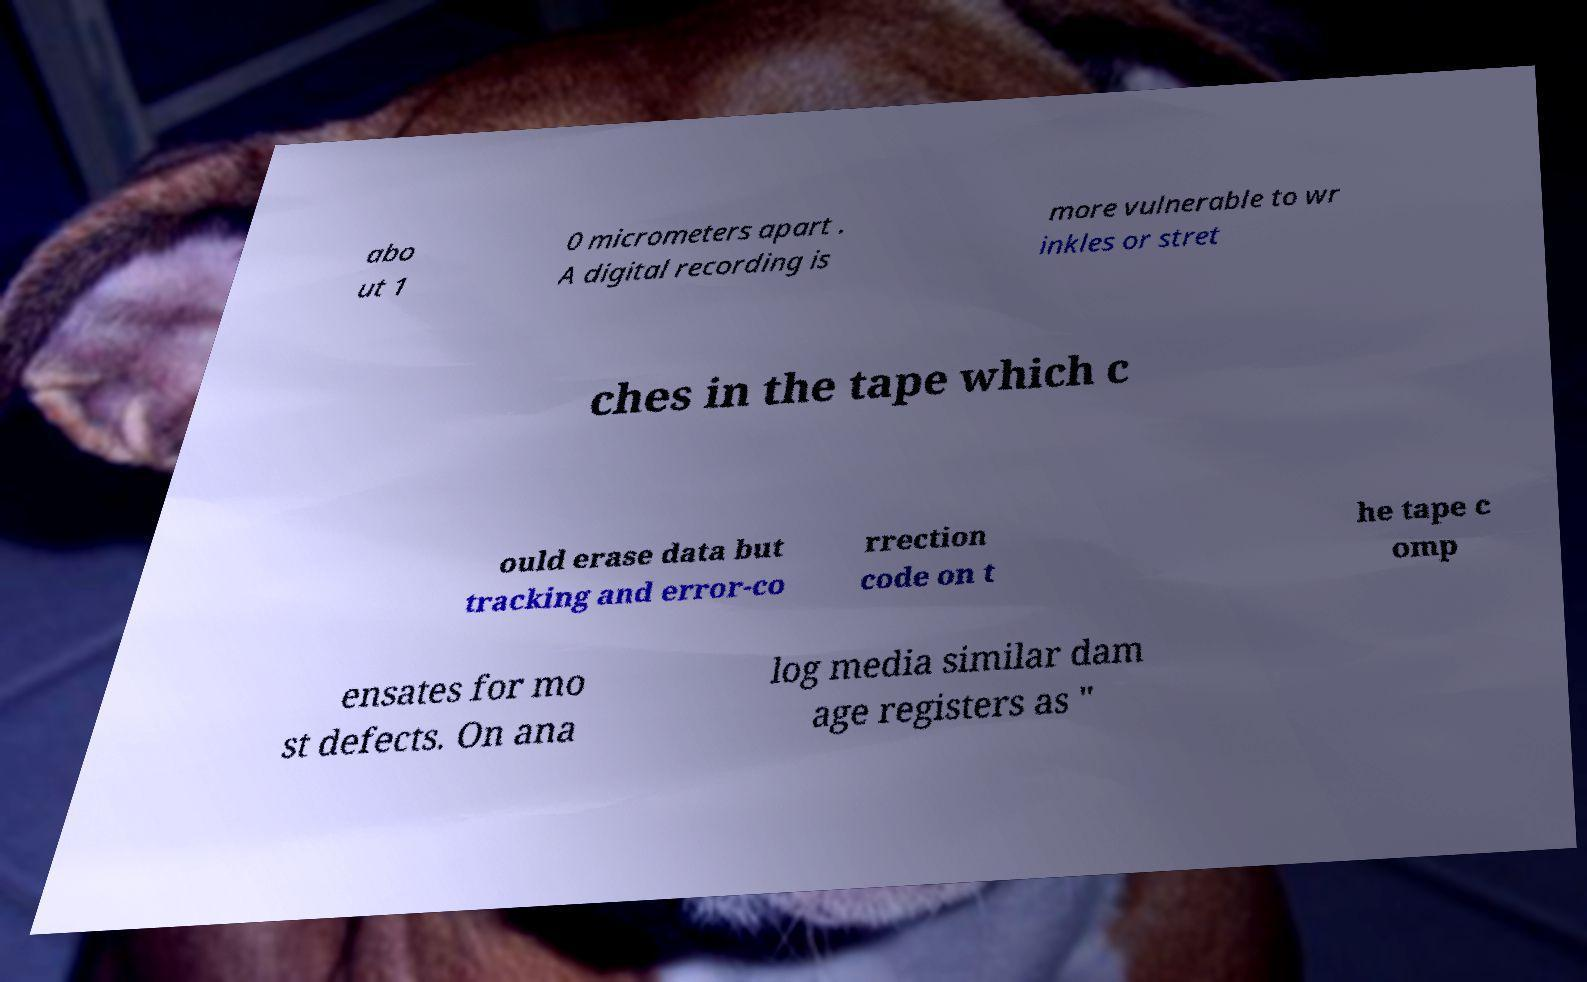Please identify and transcribe the text found in this image. abo ut 1 0 micrometers apart . A digital recording is more vulnerable to wr inkles or stret ches in the tape which c ould erase data but tracking and error-co rrection code on t he tape c omp ensates for mo st defects. On ana log media similar dam age registers as " 